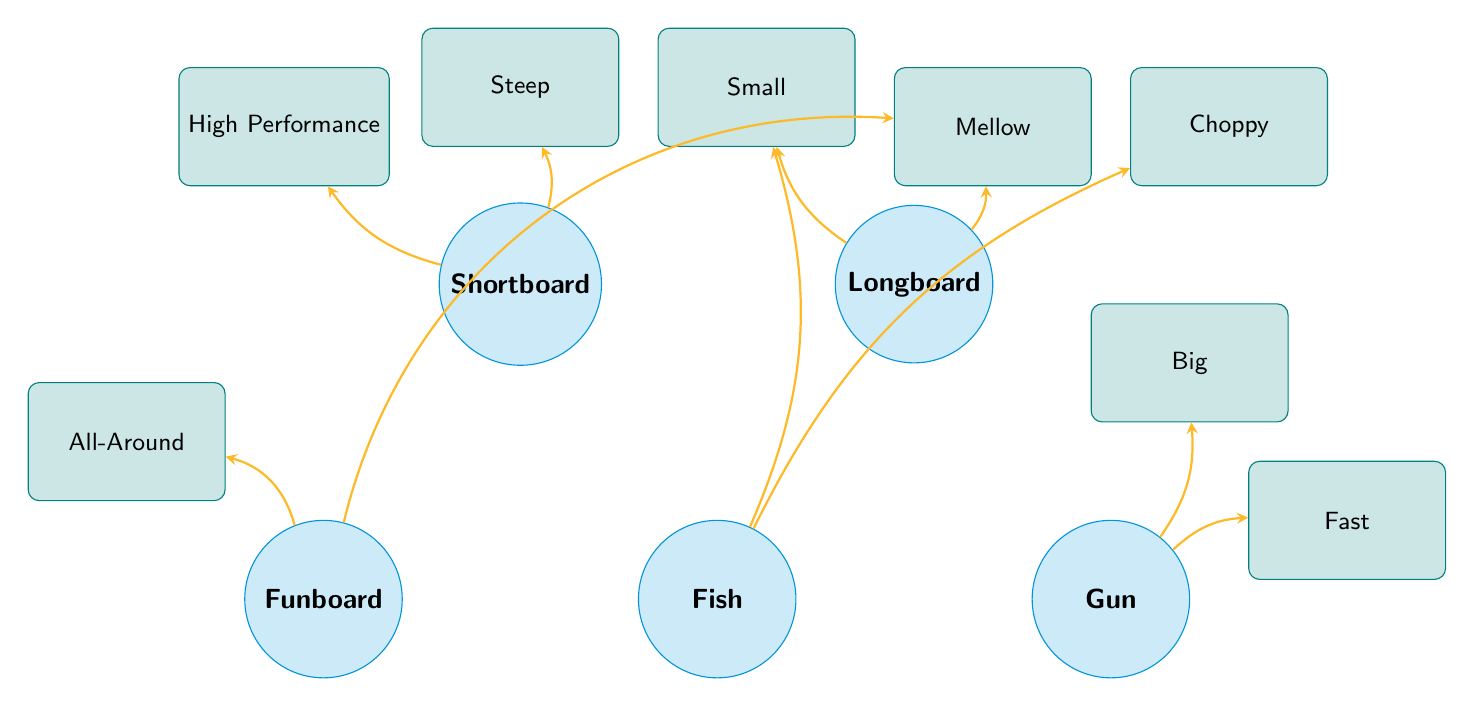What types of surfboards are connected to 'Mellow Waves'? By examining the connections in the diagram, the surfboards linked to 'Mellow Waves' are the Longboard and Funboard.
Answer: Longboard, Funboard How many wave conditions are associated with the 'Gun'? The 'Gun' surfboard is connected to two wave conditions: 'Big Waves' and 'Fast Waves.' Thus, it is associated with two wave conditions.
Answer: 2 Which surfboard type is suitable for 'Choppy Waves'? Looking at the connections, the surfboard type that connects with 'Choppy Waves' is the Fish.
Answer: Fish What is the relationship between 'Shortboard' and 'High Performance Waves'? The diagram shows a direct connection (an arrow) from 'Shortboard' to 'High Performance Waves,' indicating that the Shortboard is suitable for these waves.
Answer: Connected Which surfboard has the most wave conditions connected to it? The Funboard is associated with two wave conditions: 'All-Around Waves' and 'Mellow Waves,' which is the most among all the surfboards displayed in the diagram.
Answer: Funboard How many surfboard types are connected to 'Small Waves'? The surfboard types connected to 'Small Waves' are Longboard and Fish. Therefore, there are two surfboard types linked to this wave condition.
Answer: 2 What type of wave is suitable for Fish surfboards? The Fish surfboard is suitable for both 'Small Waves' and 'Choppy Waves,' making either of these wave conditions suitable.
Answer: Small Waves, Choppy Waves Which surfboard type is most suitable for the largest waves? The largest waves mentioned in the diagram are 'Big Waves,' which the Gun is specifically suited for, making it the most suitable surfboard type for these conditions.
Answer: Gun 